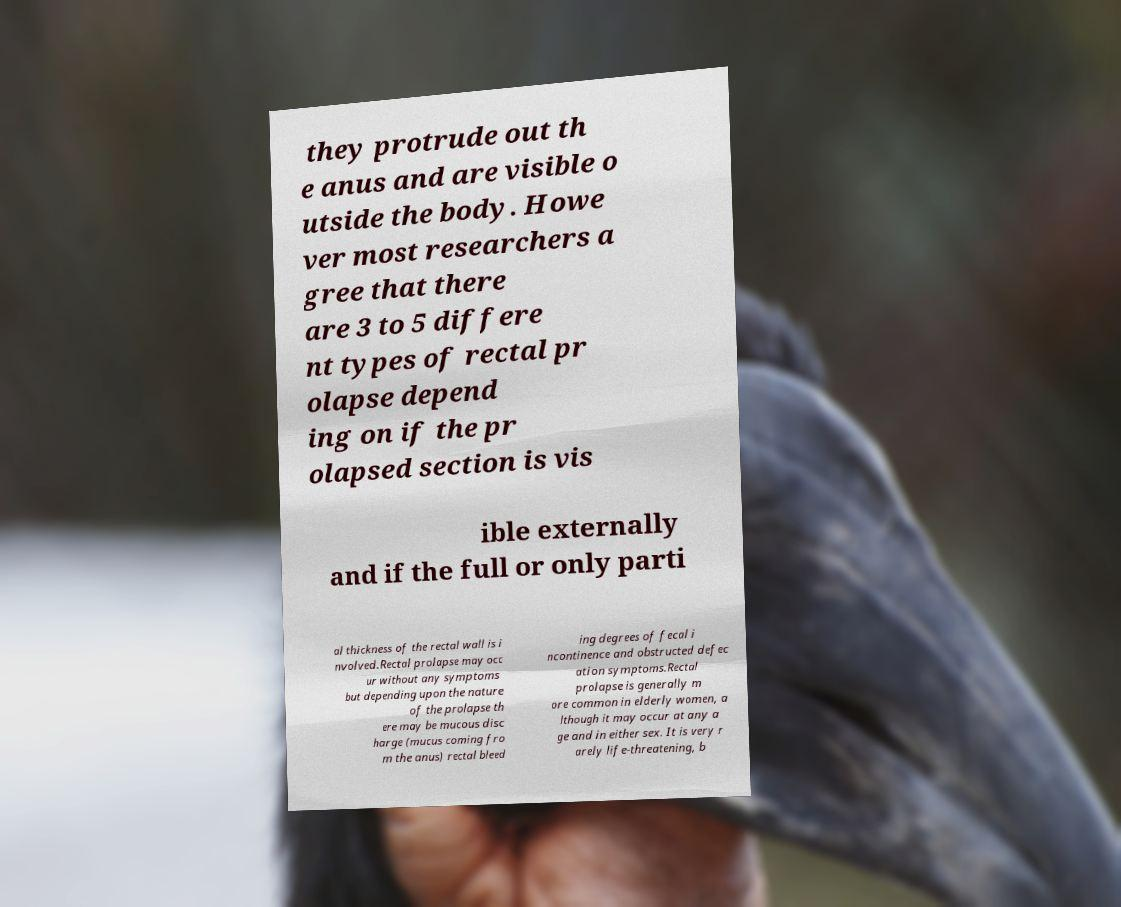There's text embedded in this image that I need extracted. Can you transcribe it verbatim? they protrude out th e anus and are visible o utside the body. Howe ver most researchers a gree that there are 3 to 5 differe nt types of rectal pr olapse depend ing on if the pr olapsed section is vis ible externally and if the full or only parti al thickness of the rectal wall is i nvolved.Rectal prolapse may occ ur without any symptoms but depending upon the nature of the prolapse th ere may be mucous disc harge (mucus coming fro m the anus) rectal bleed ing degrees of fecal i ncontinence and obstructed defec ation symptoms.Rectal prolapse is generally m ore common in elderly women, a lthough it may occur at any a ge and in either sex. It is very r arely life-threatening, b 